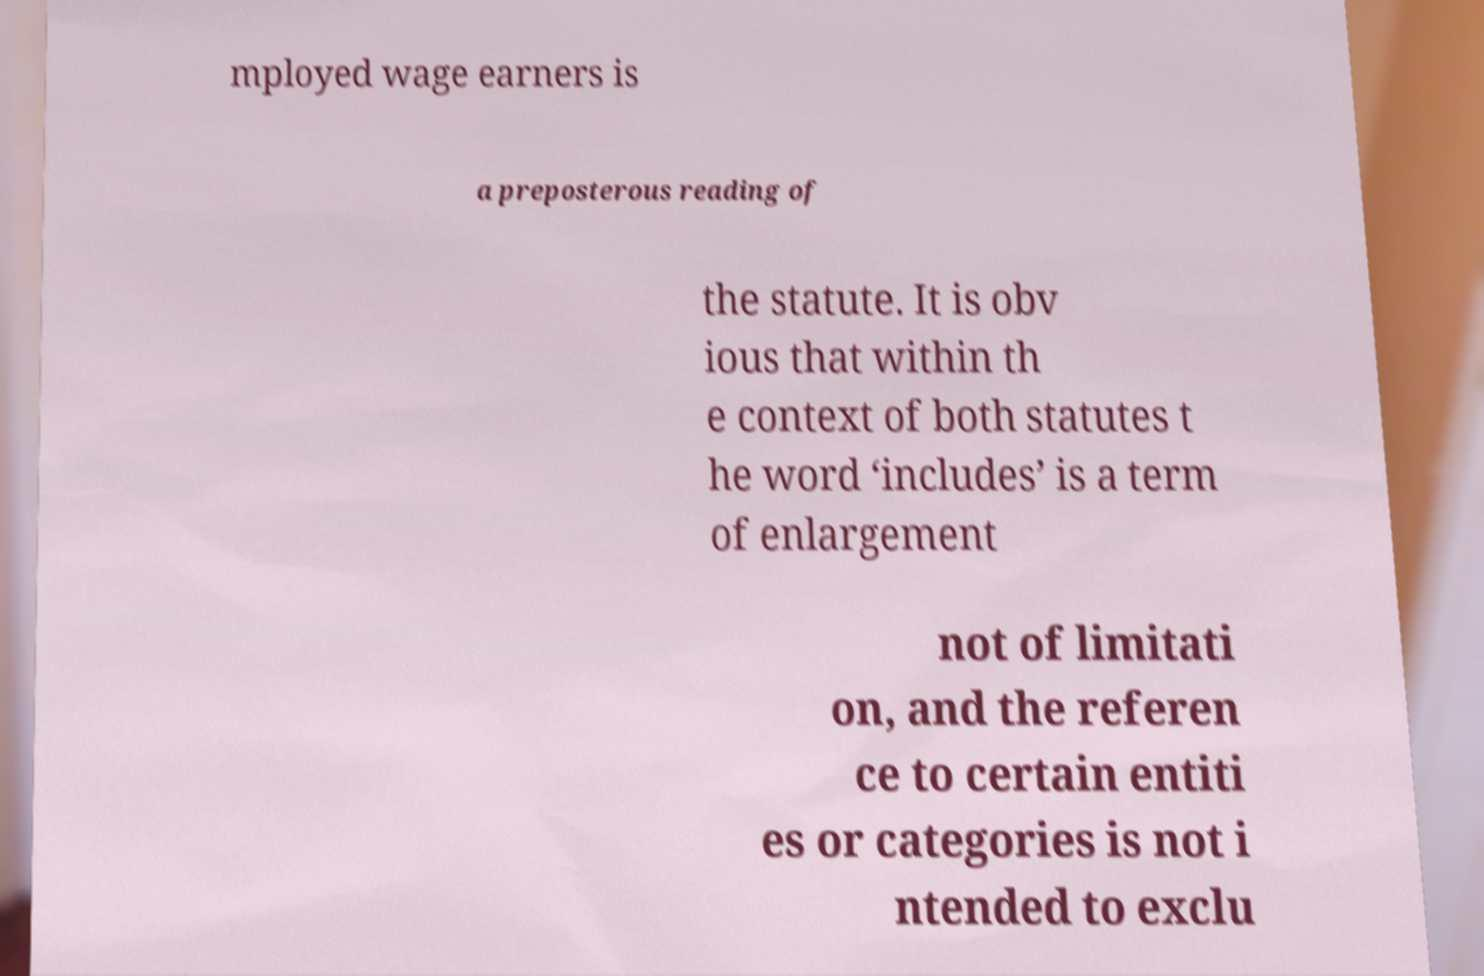Please identify and transcribe the text found in this image. mployed wage earners is a preposterous reading of the statute. It is obv ious that within th e context of both statutes t he word ‘includes’ is a term of enlargement not of limitati on, and the referen ce to certain entiti es or categories is not i ntended to exclu 